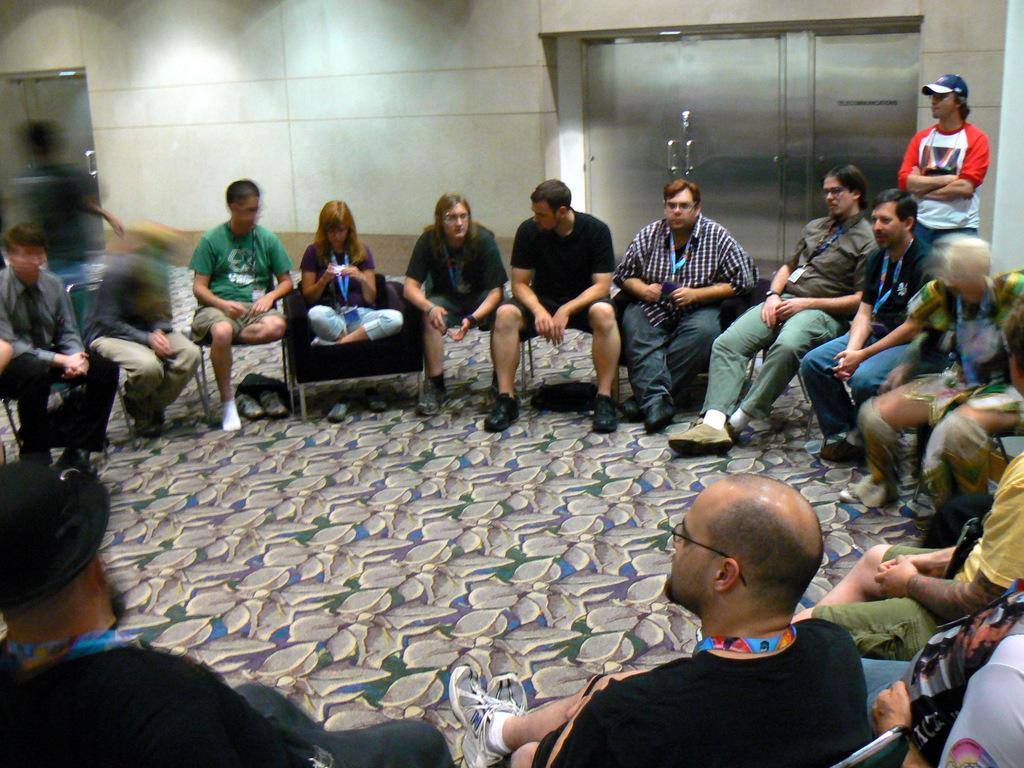What are the people in the image doing? The people in the image are sitting on chairs. What is behind the chairs in the image? There is a wall behind the chairs. What architectural features can be seen in the image? Doors are visible in the image. Where is the man located in the image? The man is standing in the top right side of the image. What type of pancake is being flipped by the man in the image? There is no man flipping a pancake in the image; the man is standing in the top right side of the image. How many trucks are visible in the image? There are no trucks visible in the image. 